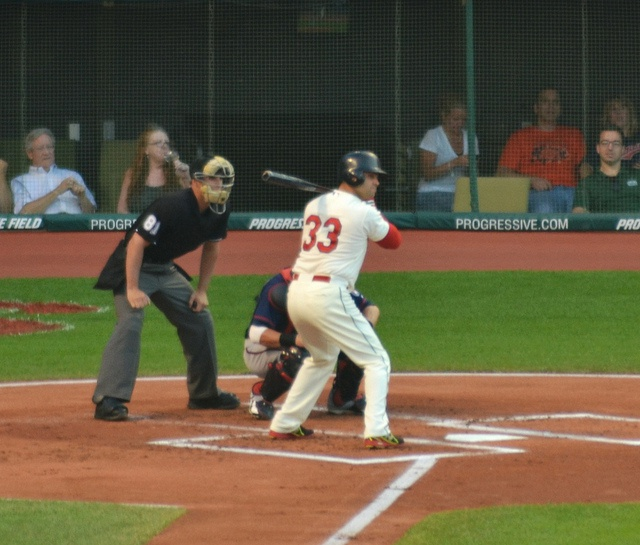Describe the objects in this image and their specific colors. I can see people in black, beige, darkgray, and brown tones, people in black, gray, brown, and darkgreen tones, people in black, gray, and maroon tones, people in black, maroon, and gray tones, and people in black, gray, and purple tones in this image. 